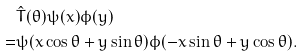Convert formula to latex. <formula><loc_0><loc_0><loc_500><loc_500>& \hat { T } ( \theta ) \psi ( x ) \phi ( y ) \\ = & \psi ( x \cos \theta + y \sin \theta ) \phi ( - x \sin \theta + y \cos \theta ) .</formula> 